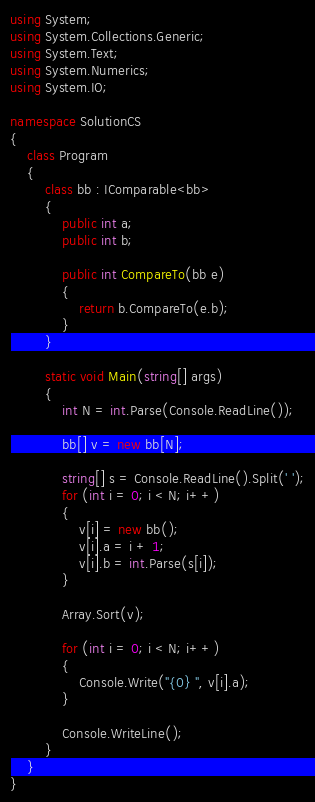Convert code to text. <code><loc_0><loc_0><loc_500><loc_500><_C#_>using System;
using System.Collections.Generic;
using System.Text;
using System.Numerics;
using System.IO;

namespace SolutionCS
{
    class Program
    {
        class bb : IComparable<bb>
        {
            public int a;
            public int b;

            public int CompareTo(bb e)
            {
                return b.CompareTo(e.b);
            }
        }

        static void Main(string[] args)
        {
            int N = int.Parse(Console.ReadLine());

            bb[] v = new bb[N];

            string[] s = Console.ReadLine().Split(' ');
            for (int i = 0; i < N; i++)
            {
                v[i] = new bb();
                v[i].a = i + 1;
                v[i].b = int.Parse(s[i]);
            }

            Array.Sort(v);

            for (int i = 0; i < N; i++)
            {
                Console.Write("{0} ", v[i].a);
            }

            Console.WriteLine();
        }
    }
}

</code> 